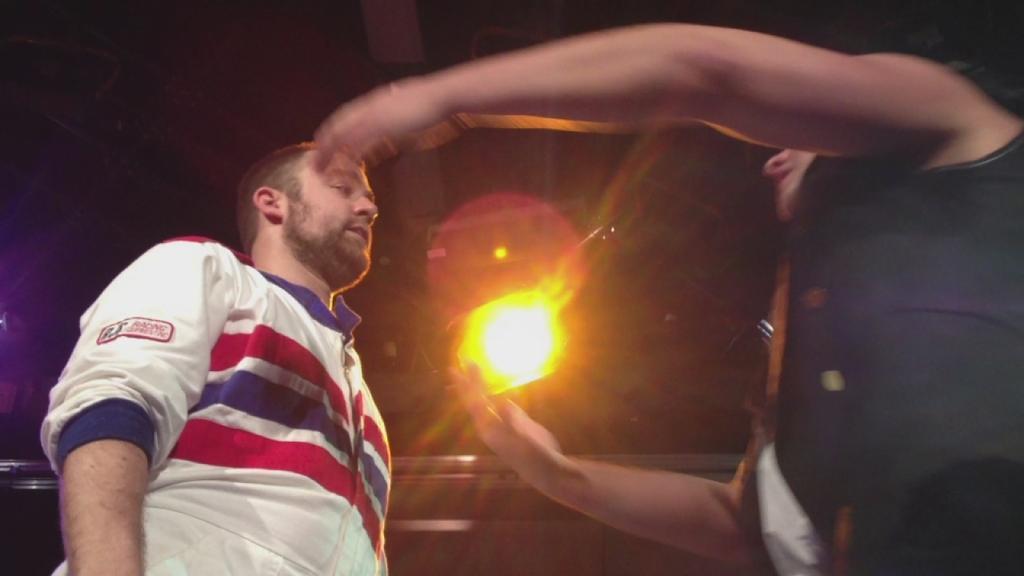Describe this image in one or two sentences. This image is taken outdoors. In the middle of the image there is a light. On the right side of the image there is a man. On the left side of the image there is another man. 